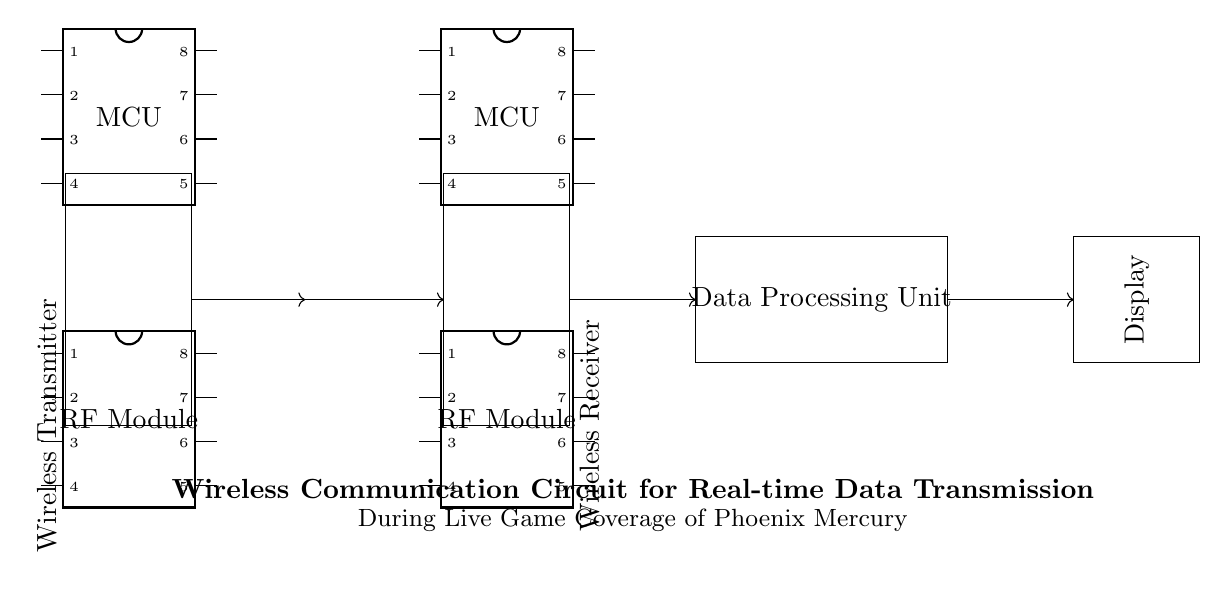What component is labeled as the primary data processing unit? The circuit includes a labeled rectangle for the Data Processing Unit, identified explicitly in the drawing.
Answer: Data Processing Unit What are the two main components of the Wireless Transmitter? By examining the circuit diagram, the two main components inside the Wireless Transmitter are the Microcontroller Unit (MCU) and the RF Module, both of which are separately indicated within the diagram.
Answer: MCU and RF Module What type of module is used in both the Wireless Transmitter and the Wireless Receiver? Both wireless devices are represented with RF Modules, indicating a uniform component for radio frequency communication.
Answer: RF Module What is the function of the antennas in this circuit? The antennas serve to facilitate wireless communication between the transmitter and receiver, allowing for the transmission and reception of signals without physical connections.
Answer: Wireless communication How many components are connected to the Wireless Receiver? Analyzing the circuit, the Wireless Receiver has three directly connected components: its MCU, RF Module, and an antenna, as depicted in the structure.
Answer: Three components What is the direction of data flow in the circuit? Tracing the arrows in the circuit diagram shows that data flows from the Wireless Transmitter to the Wireless Receiver, then to the Data Processing Unit, and finally to the Display, illustrating a clear sequence of data transfer.
Answer: From Transmitter to Receiver to Processing Unit to Display 